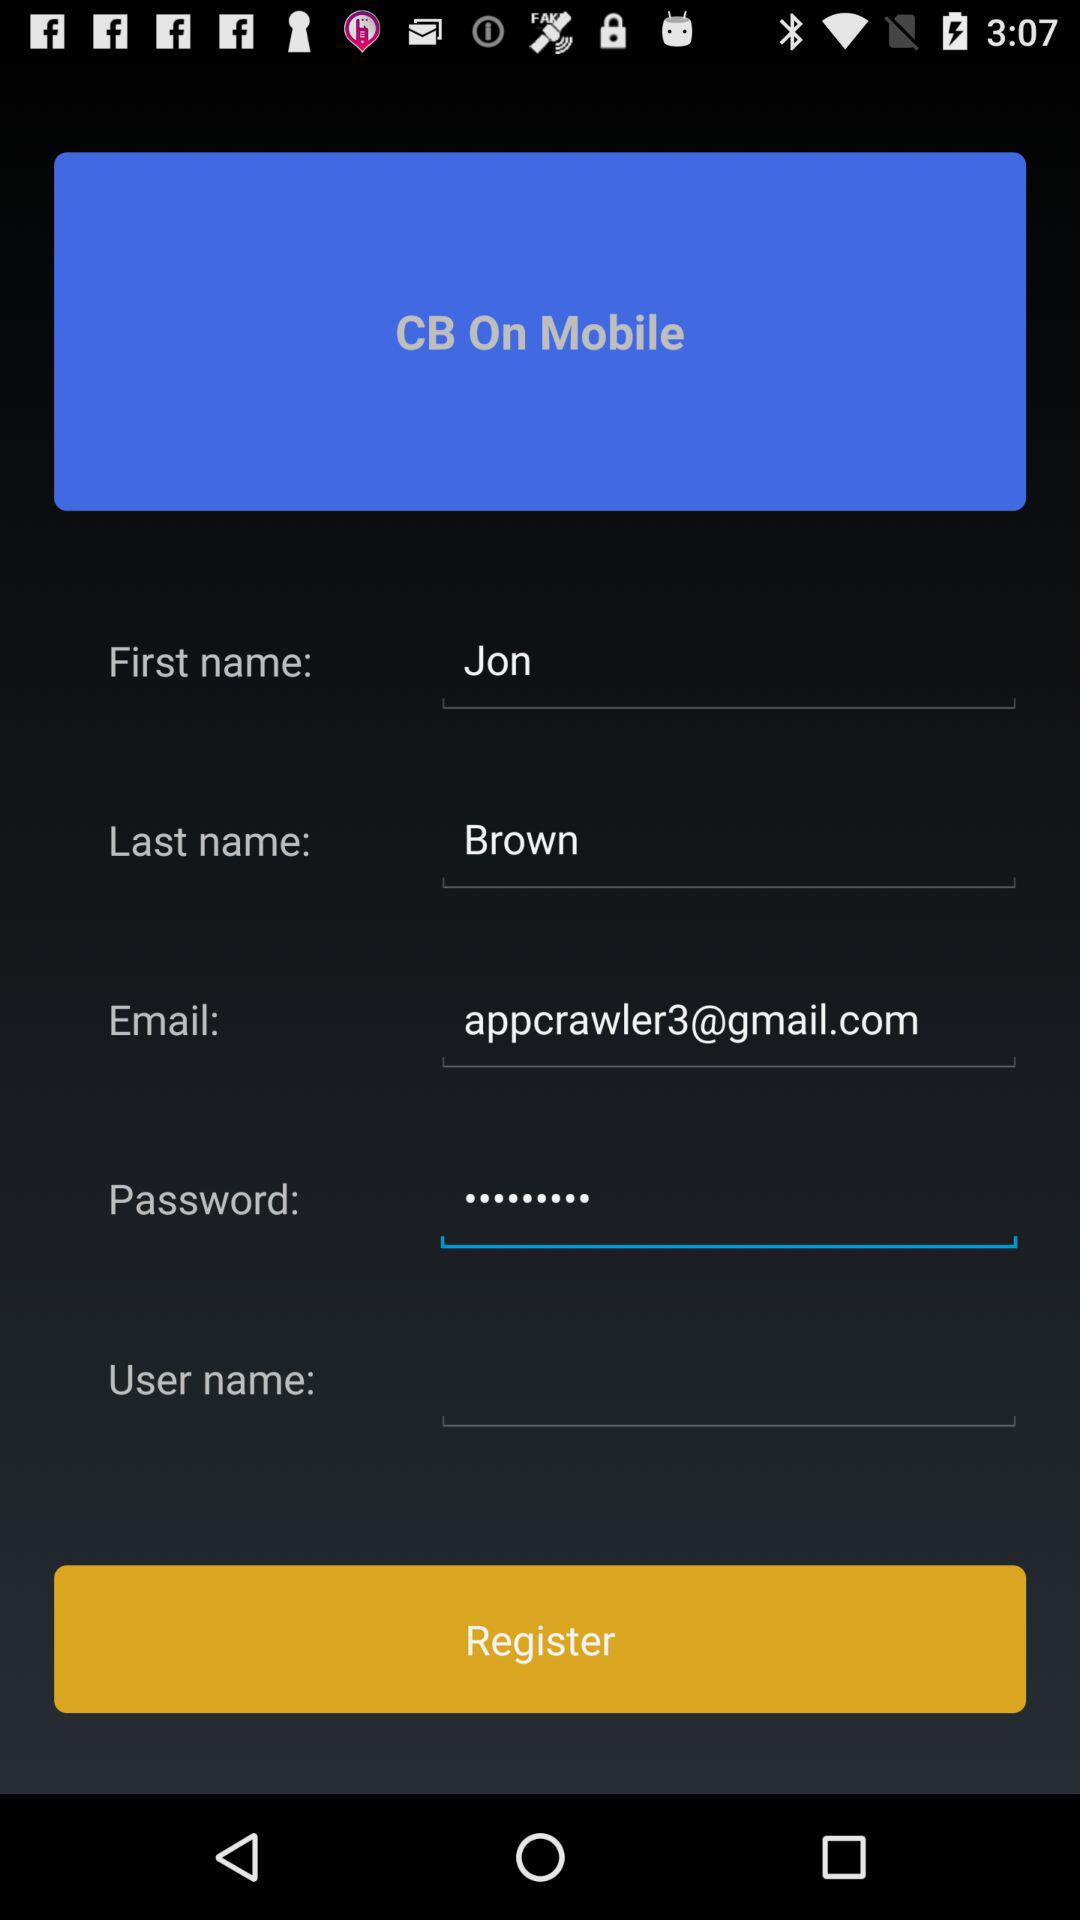What is the email address? The email address is appcrawler3@gmail.com. 